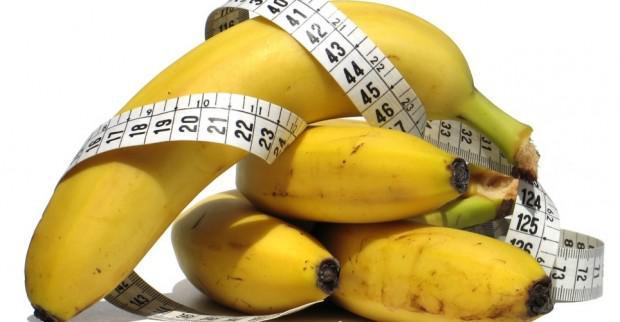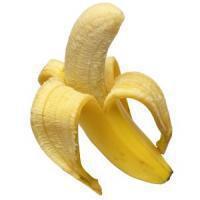The first image is the image on the left, the second image is the image on the right. Considering the images on both sides, is "Atleast one photo in the pair is a single half peeled banana" valid? Answer yes or no. Yes. 